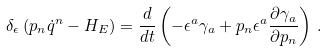<formula> <loc_0><loc_0><loc_500><loc_500>\delta _ { \epsilon } \left ( p _ { n } \dot { q } ^ { n } - H _ { E } \right ) = \frac { d } { d t } \left ( - \epsilon ^ { a } \gamma _ { a } + p _ { n } \epsilon ^ { a } \frac { \partial \gamma _ { a } } { \partial p _ { n } } \right ) \, .</formula> 